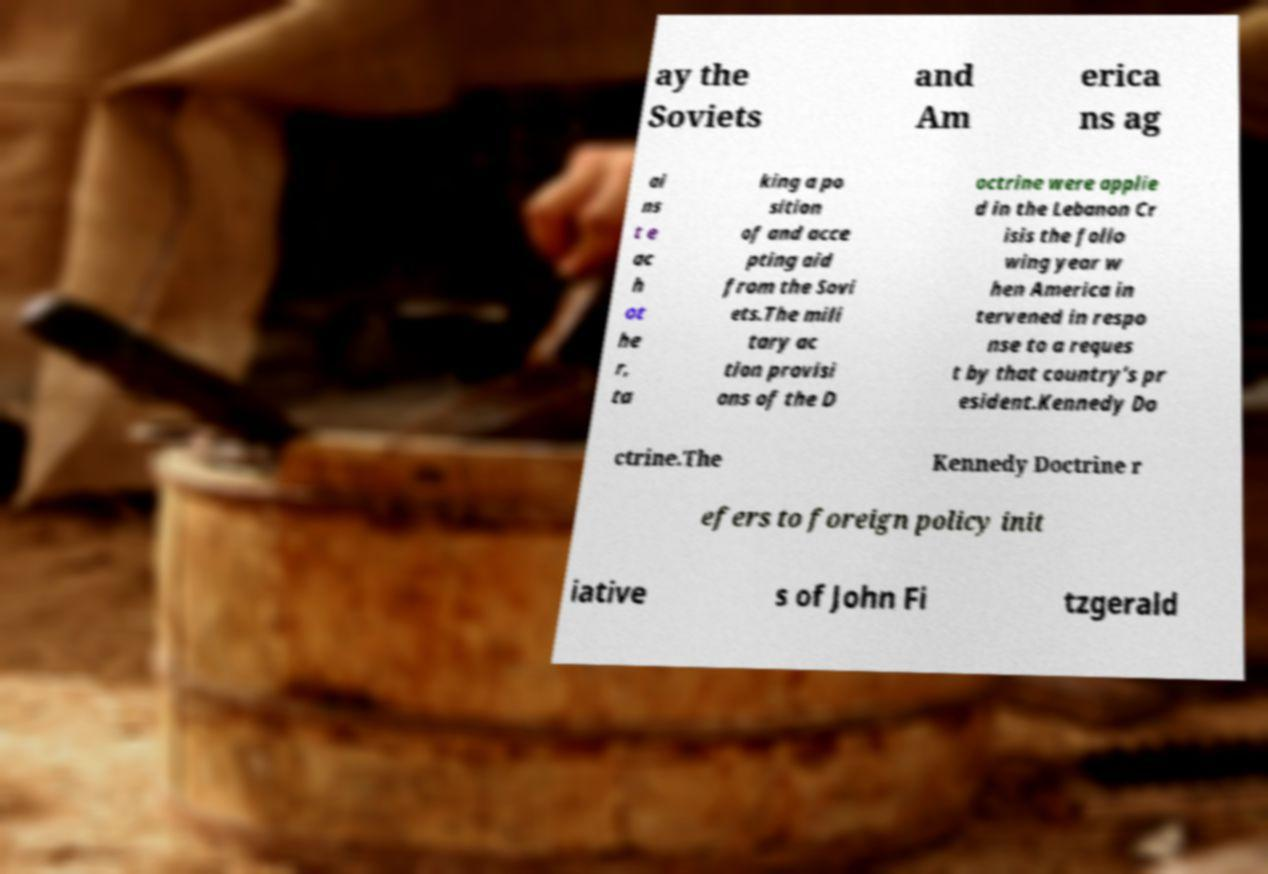Can you read and provide the text displayed in the image?This photo seems to have some interesting text. Can you extract and type it out for me? ay the Soviets and Am erica ns ag ai ns t e ac h ot he r, ta king a po sition of and acce pting aid from the Sovi ets.The mili tary ac tion provisi ons of the D octrine were applie d in the Lebanon Cr isis the follo wing year w hen America in tervened in respo nse to a reques t by that country's pr esident.Kennedy Do ctrine.The Kennedy Doctrine r efers to foreign policy init iative s of John Fi tzgerald 